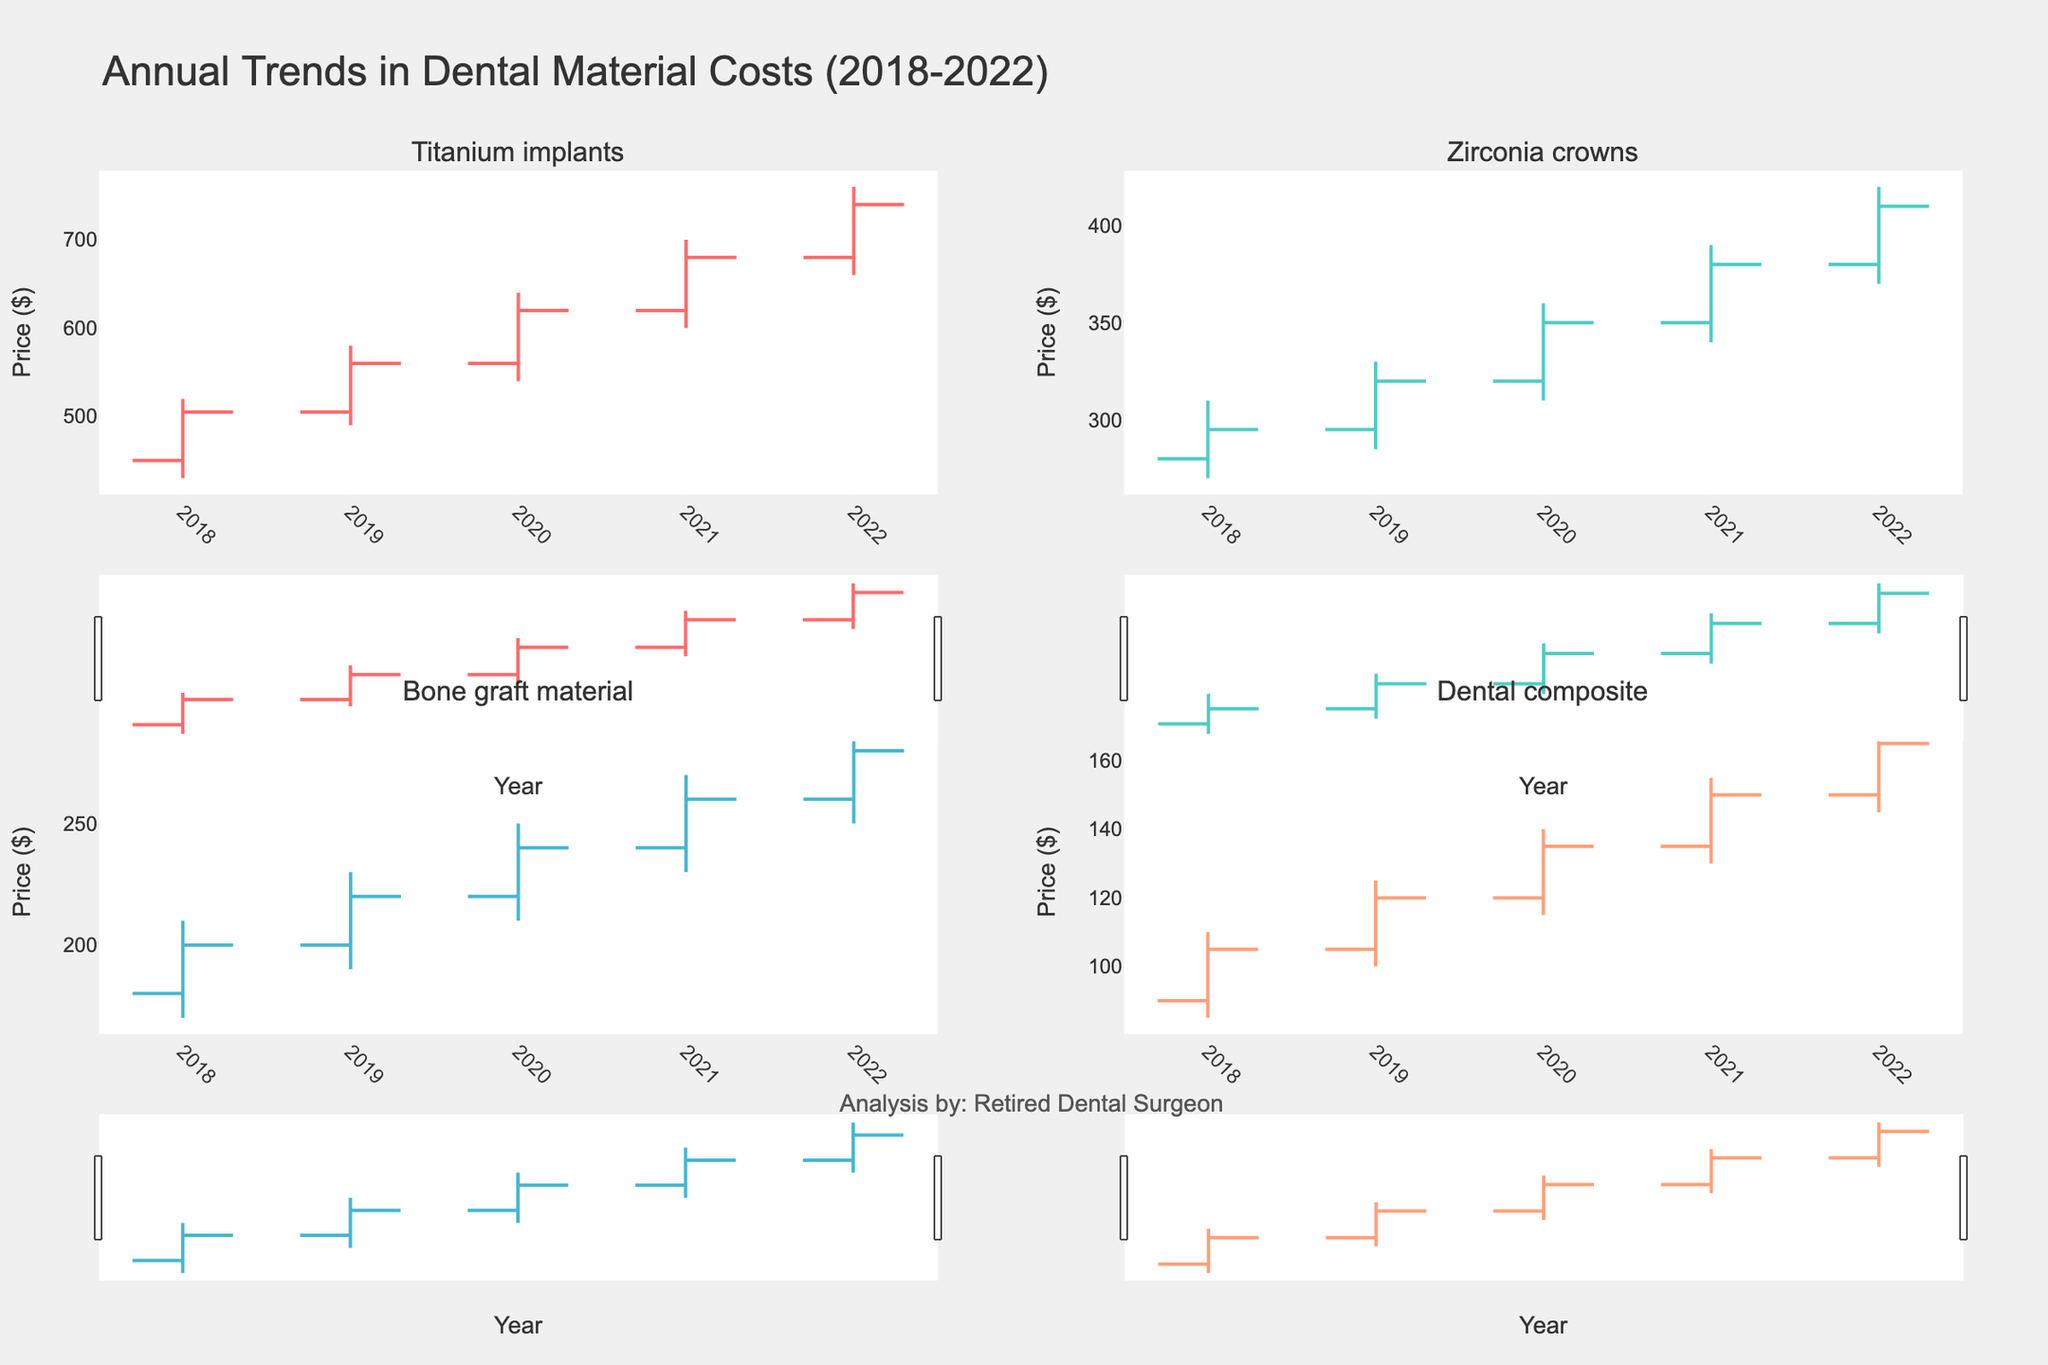what is the overall trend in the cost of titanium implants from 2018 to 2022? The data shows a steady increase in the costs of titanium implants every year. The opening price in 2018 was $450, and it reached a closing price of $740 in 2022. Thus, the overall trend for titanium implants is upward.
Answer: Upward Which material had the smallest range in cost in the year 2022? To find this, look at the difference between the high and low prices for each material in 2022. Titanium implants had a range of $100 (760 - 660), Zirconia crowns had a range of $50 (420 - 370), Bone graft material had a range of $40 (290 - 250), and Dental composite had a range of $25 (170 - 145). Therefore, Dental composite had the smallest range.
Answer: Dental composite How did the closing price of zirconia crowns change from 2019 to 2020? The closing price of zirconia crowns in 2019 was $320 and in 2020 it was $350. Therefore, it increased by $30.
Answer: Increased by $30 Which material consistently increased in both open and close prices every year? By checking each material's opening and closing prices for each year, we see that Titanium implants open and close prices increased steadily every year from 2018 to 2022.
Answer: Titanium implants In which year did bone graft material have the highest closing price? Looking at the closing prices for each year for bone graft material, the highest closing price is found in 2022, which was $280.
Answer: 2022 Between Titanium implants and Zirconia crowns, which had a larger increase in closing price from 2018 to 2022? The closing price of Titanium implants increased from $505 to $740, an increase of $235. Zirconia crowns increased from $295 to $410, an increase of $115. Thus, Titanium implants had a larger increase.
Answer: Titanium implants What was the average opening price for dental composites from 2018 to 2022? The opening prices for dental composites from 2018 to 2022 are $90, $105, $120, $135, and $150. The sum is 600, and the average is 600/5 = 120.
Answer: 120 In 2021, which material had the highest high price and what was it? By looking at the high prices for each material in 2021, Titanium implants had the highest high price at $700.
Answer: Titanium implants, $700 What is the trend in the closing prices of bone graft material from 2018 to 2022? The closing prices for bone graft material from 2018 to 2022 are $200, $220, $240, $260, and $280. This shows a consistent upward trend every year.
Answer: Upward Compare the closing price of Dental composite in 2018 with the low price in 2019. Which is higher? The closing price of Dental composite in 2018 was $105. The low price in 2019 was $100. Therefore, the closing price in 2018 is higher.
Answer: 2018 Closing price 